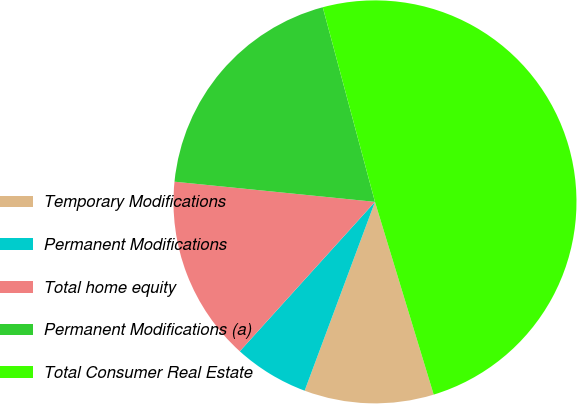Convert chart to OTSL. <chart><loc_0><loc_0><loc_500><loc_500><pie_chart><fcel>Temporary Modifications<fcel>Permanent Modifications<fcel>Total home equity<fcel>Permanent Modifications (a)<fcel>Total Consumer Real Estate<nl><fcel>10.38%<fcel>6.03%<fcel>14.89%<fcel>19.23%<fcel>49.46%<nl></chart> 